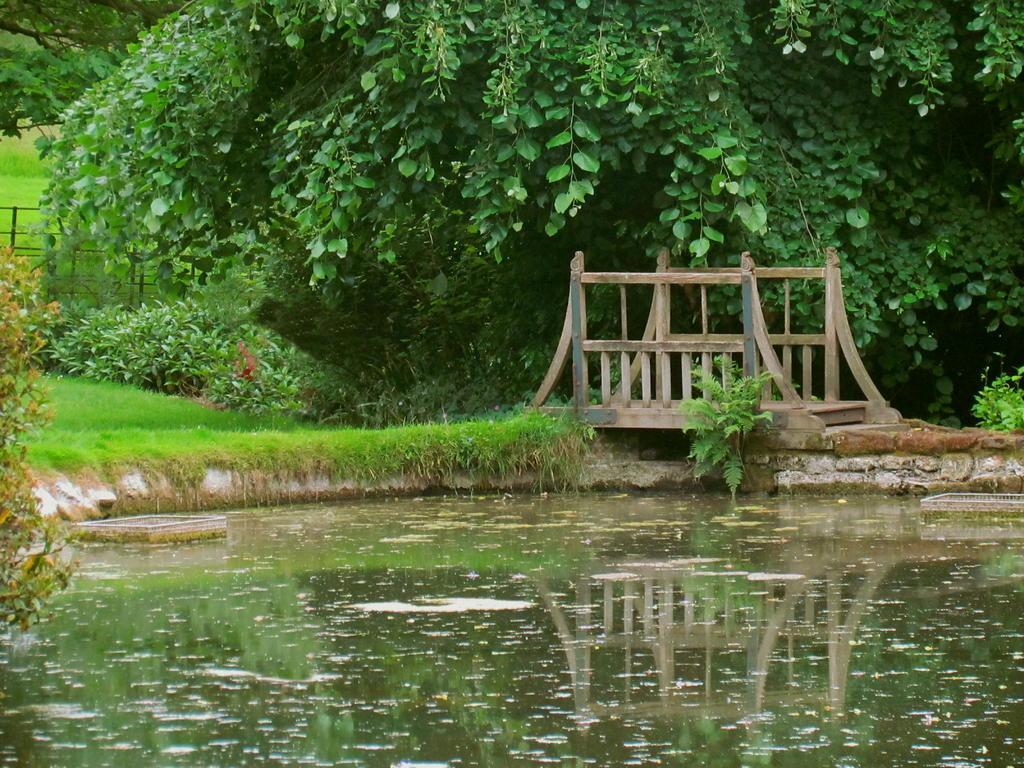Describe this image in one or two sentences. In this image I can see the lake and I can see a wooden bridge visible beside the lake ,at the top I can see trees and bushes and grass in the middle 